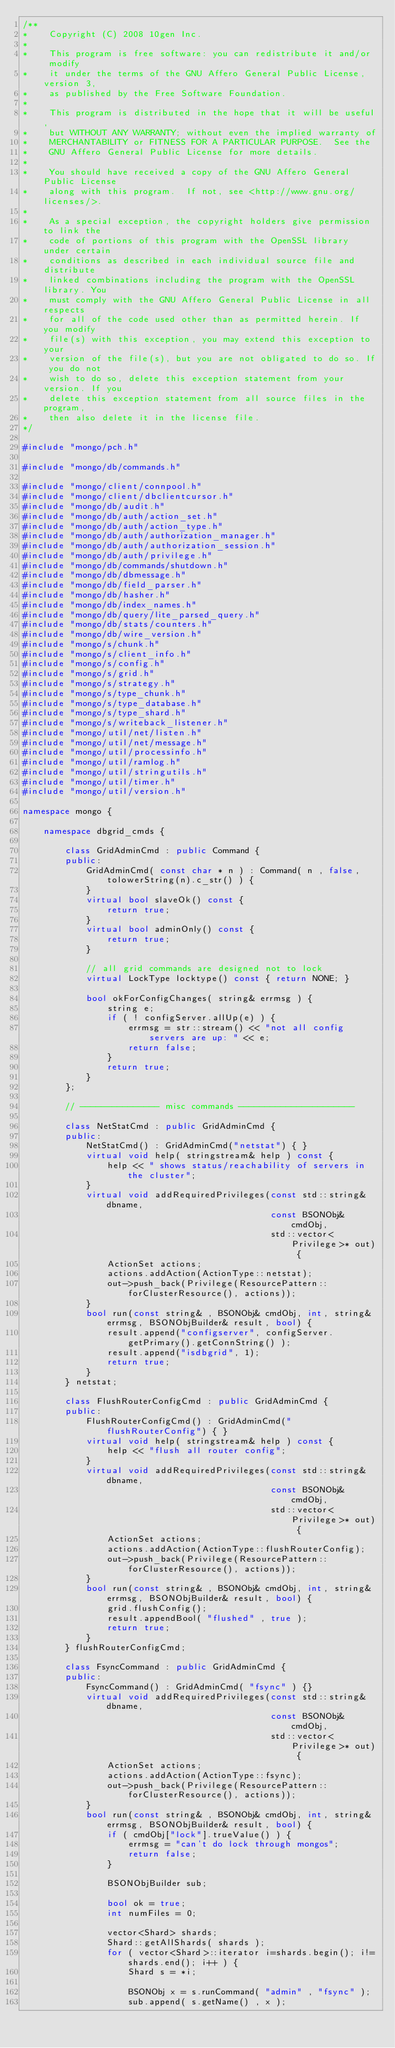<code> <loc_0><loc_0><loc_500><loc_500><_C++_>/**
*    Copyright (C) 2008 10gen Inc.
*
*    This program is free software: you can redistribute it and/or  modify
*    it under the terms of the GNU Affero General Public License, version 3,
*    as published by the Free Software Foundation.
*
*    This program is distributed in the hope that it will be useful,
*    but WITHOUT ANY WARRANTY; without even the implied warranty of
*    MERCHANTABILITY or FITNESS FOR A PARTICULAR PURPOSE.  See the
*    GNU Affero General Public License for more details.
*
*    You should have received a copy of the GNU Affero General Public License
*    along with this program.  If not, see <http://www.gnu.org/licenses/>.
*
*    As a special exception, the copyright holders give permission to link the
*    code of portions of this program with the OpenSSL library under certain
*    conditions as described in each individual source file and distribute
*    linked combinations including the program with the OpenSSL library. You
*    must comply with the GNU Affero General Public License in all respects
*    for all of the code used other than as permitted herein. If you modify
*    file(s) with this exception, you may extend this exception to your
*    version of the file(s), but you are not obligated to do so. If you do not
*    wish to do so, delete this exception statement from your version. If you
*    delete this exception statement from all source files in the program,
*    then also delete it in the license file.
*/

#include "mongo/pch.h"

#include "mongo/db/commands.h"

#include "mongo/client/connpool.h"
#include "mongo/client/dbclientcursor.h"
#include "mongo/db/audit.h"
#include "mongo/db/auth/action_set.h"
#include "mongo/db/auth/action_type.h"
#include "mongo/db/auth/authorization_manager.h"
#include "mongo/db/auth/authorization_session.h"
#include "mongo/db/auth/privilege.h"
#include "mongo/db/commands/shutdown.h"
#include "mongo/db/dbmessage.h"
#include "mongo/db/field_parser.h"
#include "mongo/db/hasher.h"
#include "mongo/db/index_names.h"
#include "mongo/db/query/lite_parsed_query.h"
#include "mongo/db/stats/counters.h"
#include "mongo/db/wire_version.h"
#include "mongo/s/chunk.h"
#include "mongo/s/client_info.h"
#include "mongo/s/config.h"
#include "mongo/s/grid.h"
#include "mongo/s/strategy.h"
#include "mongo/s/type_chunk.h"
#include "mongo/s/type_database.h"
#include "mongo/s/type_shard.h"
#include "mongo/s/writeback_listener.h"
#include "mongo/util/net/listen.h"
#include "mongo/util/net/message.h"
#include "mongo/util/processinfo.h"
#include "mongo/util/ramlog.h"
#include "mongo/util/stringutils.h"
#include "mongo/util/timer.h"
#include "mongo/util/version.h"

namespace mongo {

    namespace dbgrid_cmds {

        class GridAdminCmd : public Command {
        public:
            GridAdminCmd( const char * n ) : Command( n , false, tolowerString(n).c_str() ) {
            }
            virtual bool slaveOk() const {
                return true;
            }
            virtual bool adminOnly() const {
                return true;
            }

            // all grid commands are designed not to lock
            virtual LockType locktype() const { return NONE; }

            bool okForConfigChanges( string& errmsg ) {
                string e;
                if ( ! configServer.allUp(e) ) {
                    errmsg = str::stream() << "not all config servers are up: " << e;
                    return false;
                }
                return true;
            }
        };

        // --------------- misc commands ----------------------

        class NetStatCmd : public GridAdminCmd {
        public:
            NetStatCmd() : GridAdminCmd("netstat") { }
            virtual void help( stringstream& help ) const {
                help << " shows status/reachability of servers in the cluster";
            }
            virtual void addRequiredPrivileges(const std::string& dbname,
                                               const BSONObj& cmdObj,
                                               std::vector<Privilege>* out) {
                ActionSet actions;
                actions.addAction(ActionType::netstat);
                out->push_back(Privilege(ResourcePattern::forClusterResource(), actions));
            }
            bool run(const string& , BSONObj& cmdObj, int, string& errmsg, BSONObjBuilder& result, bool) {
                result.append("configserver", configServer.getPrimary().getConnString() );
                result.append("isdbgrid", 1);
                return true;
            }
        } netstat;

        class FlushRouterConfigCmd : public GridAdminCmd {
        public:
            FlushRouterConfigCmd() : GridAdminCmd("flushRouterConfig") { }
            virtual void help( stringstream& help ) const {
                help << "flush all router config";
            }
            virtual void addRequiredPrivileges(const std::string& dbname,
                                               const BSONObj& cmdObj,
                                               std::vector<Privilege>* out) {
                ActionSet actions;
                actions.addAction(ActionType::flushRouterConfig);
                out->push_back(Privilege(ResourcePattern::forClusterResource(), actions));
            }
            bool run(const string& , BSONObj& cmdObj, int, string& errmsg, BSONObjBuilder& result, bool) {
                grid.flushConfig();
                result.appendBool( "flushed" , true );
                return true;
            }
        } flushRouterConfigCmd;

        class FsyncCommand : public GridAdminCmd {
        public:
            FsyncCommand() : GridAdminCmd( "fsync" ) {}
            virtual void addRequiredPrivileges(const std::string& dbname,
                                               const BSONObj& cmdObj,
                                               std::vector<Privilege>* out) {
                ActionSet actions;
                actions.addAction(ActionType::fsync);
                out->push_back(Privilege(ResourcePattern::forClusterResource(), actions));
            }
            bool run(const string& , BSONObj& cmdObj, int, string& errmsg, BSONObjBuilder& result, bool) {
                if ( cmdObj["lock"].trueValue() ) {
                    errmsg = "can't do lock through mongos";
                    return false;
                }

                BSONObjBuilder sub;

                bool ok = true;
                int numFiles = 0;

                vector<Shard> shards;
                Shard::getAllShards( shards );
                for ( vector<Shard>::iterator i=shards.begin(); i!=shards.end(); i++ ) {
                    Shard s = *i;

                    BSONObj x = s.runCommand( "admin" , "fsync" );
                    sub.append( s.getName() , x );
</code> 